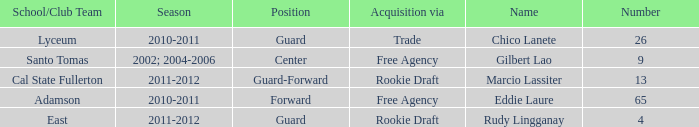What season had Marcio Lassiter? 2011-2012. 